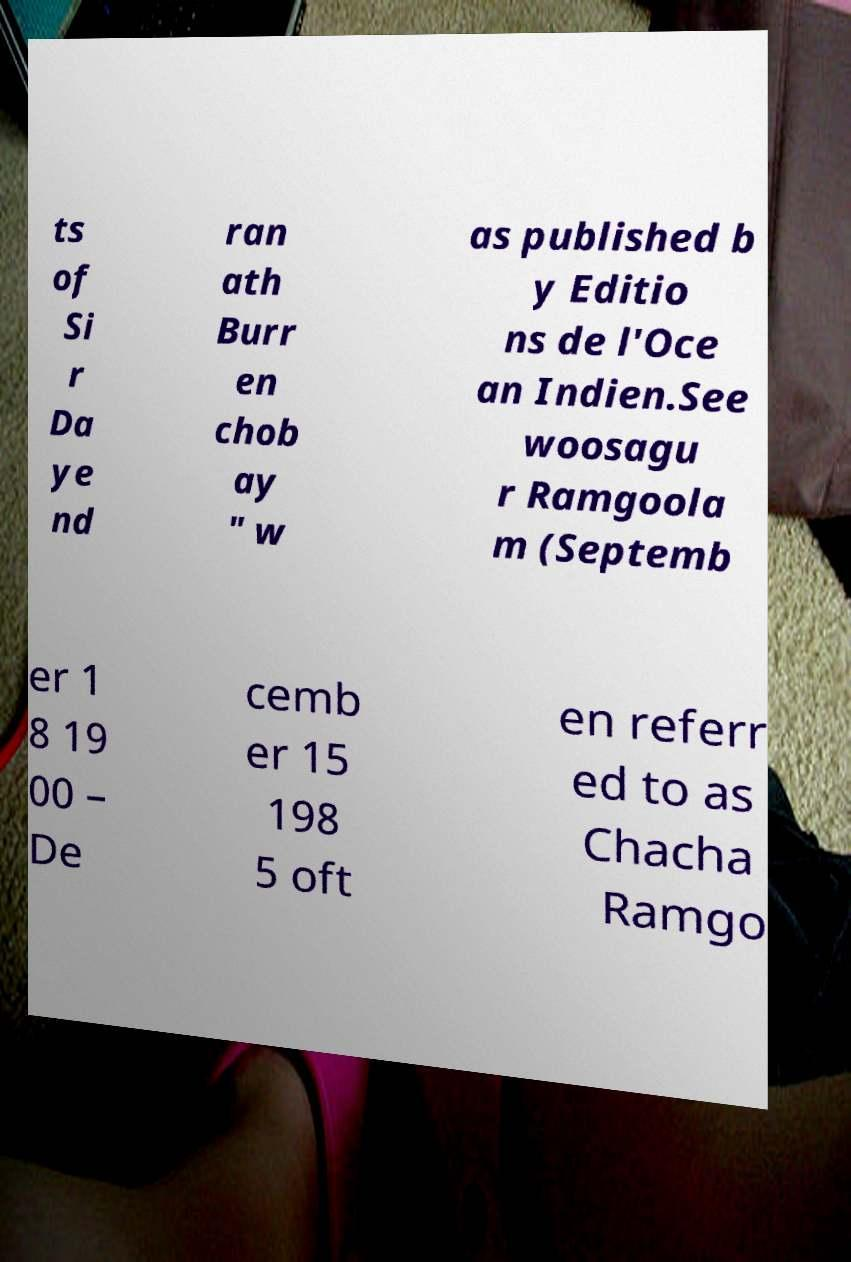I need the written content from this picture converted into text. Can you do that? ts of Si r Da ye nd ran ath Burr en chob ay " w as published b y Editio ns de l'Oce an Indien.See woosagu r Ramgoola m (Septemb er 1 8 19 00 – De cemb er 15 198 5 oft en referr ed to as Chacha Ramgo 